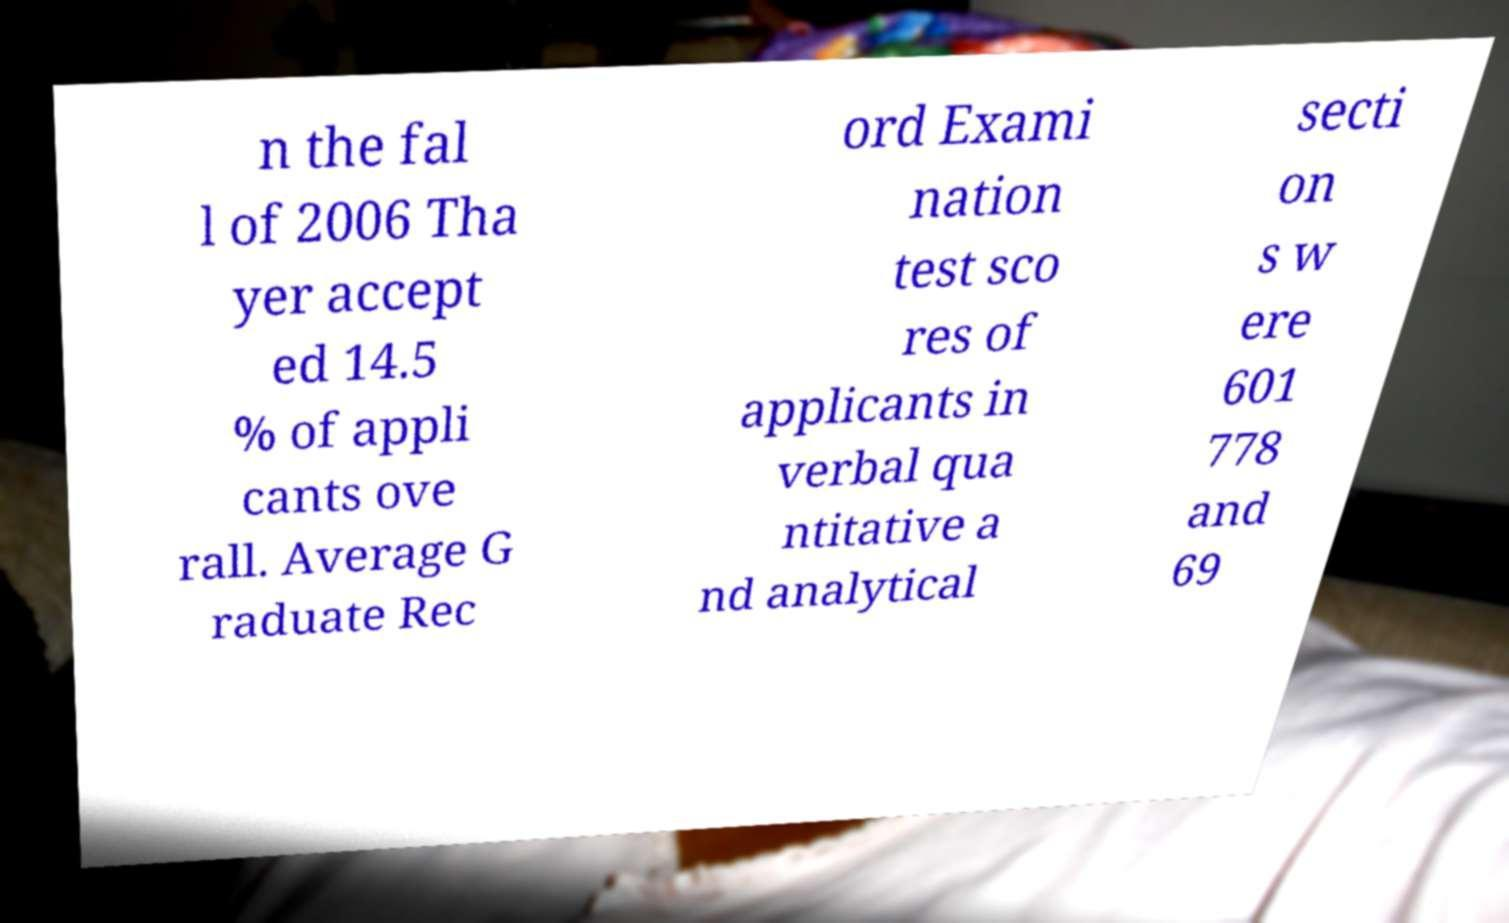Could you extract and type out the text from this image? n the fal l of 2006 Tha yer accept ed 14.5 % of appli cants ove rall. Average G raduate Rec ord Exami nation test sco res of applicants in verbal qua ntitative a nd analytical secti on s w ere 601 778 and 69 